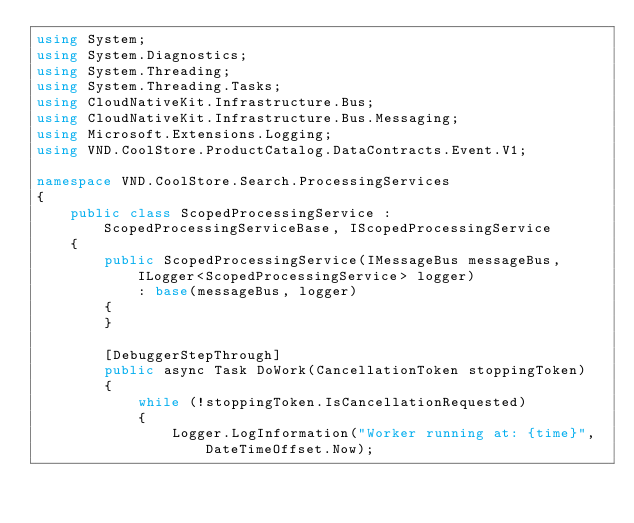Convert code to text. <code><loc_0><loc_0><loc_500><loc_500><_C#_>using System;
using System.Diagnostics;
using System.Threading;
using System.Threading.Tasks;
using CloudNativeKit.Infrastructure.Bus;
using CloudNativeKit.Infrastructure.Bus.Messaging;
using Microsoft.Extensions.Logging;
using VND.CoolStore.ProductCatalog.DataContracts.Event.V1;

namespace VND.CoolStore.Search.ProcessingServices
{
    public class ScopedProcessingService : ScopedProcessingServiceBase, IScopedProcessingService
    {
        public ScopedProcessingService(IMessageBus messageBus, ILogger<ScopedProcessingService> logger)
            : base(messageBus, logger)
        {
        }

        [DebuggerStepThrough]
        public async Task DoWork(CancellationToken stoppingToken)
        {
            while (!stoppingToken.IsCancellationRequested)
            {
                Logger.LogInformation("Worker running at: {time}", DateTimeOffset.Now);
</code> 